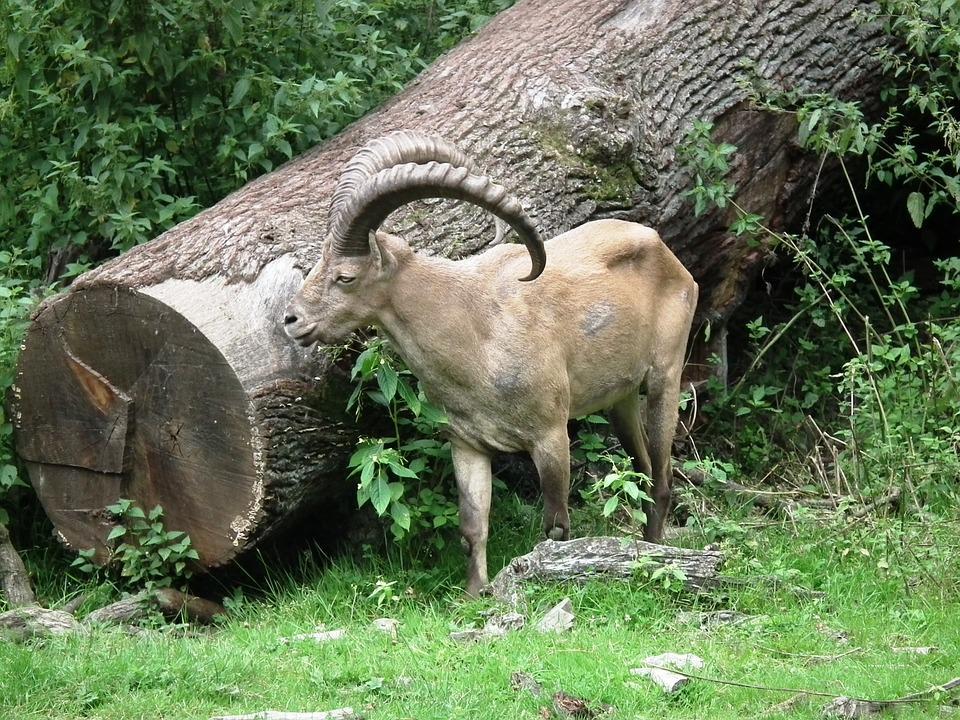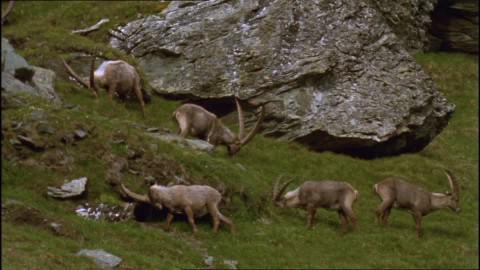The first image is the image on the left, the second image is the image on the right. Analyze the images presented: Is the assertion "a single Ibex is eating grass" valid? Answer yes or no. No. 